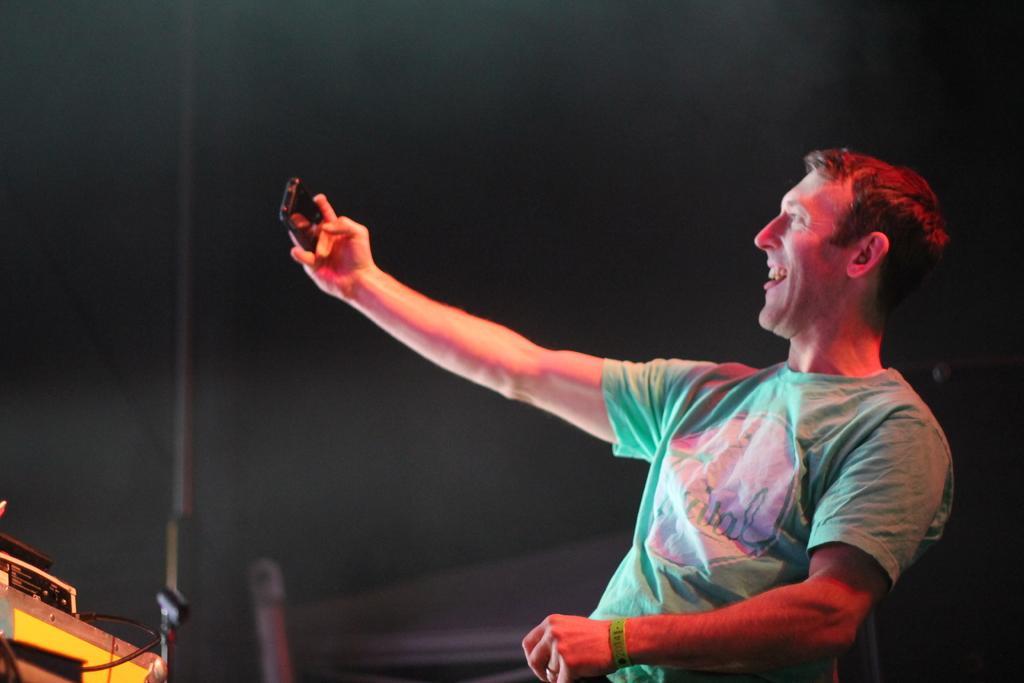How would you summarize this image in a sentence or two? In this picture we can see a person,he is smiling,he is holding a mobile and in the background we can see it is dark. 